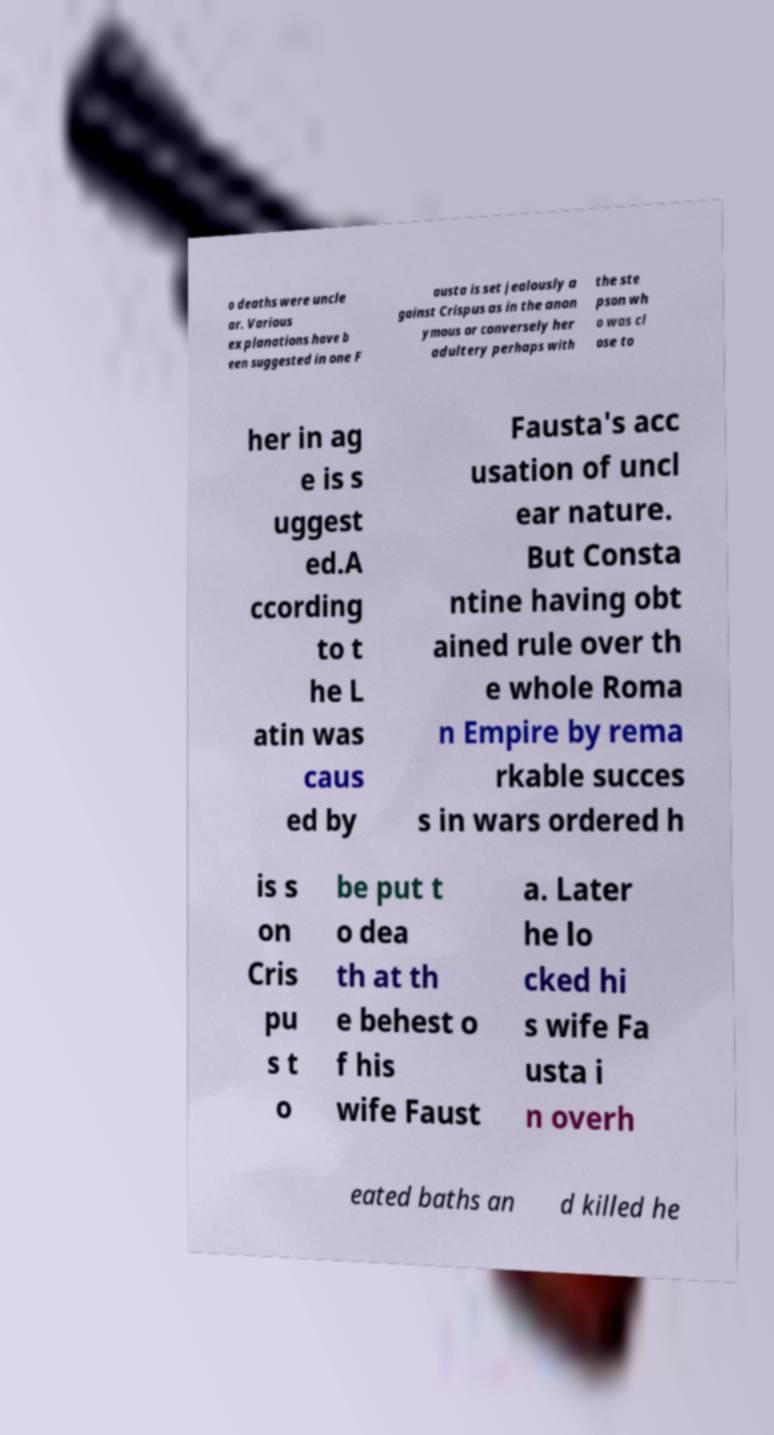Could you extract and type out the text from this image? o deaths were uncle ar. Various explanations have b een suggested in one F austa is set jealously a gainst Crispus as in the anon ymous or conversely her adultery perhaps with the ste pson wh o was cl ose to her in ag e is s uggest ed.A ccording to t he L atin was caus ed by Fausta's acc usation of uncl ear nature. But Consta ntine having obt ained rule over th e whole Roma n Empire by rema rkable succes s in wars ordered h is s on Cris pu s t o be put t o dea th at th e behest o f his wife Faust a. Later he lo cked hi s wife Fa usta i n overh eated baths an d killed he 